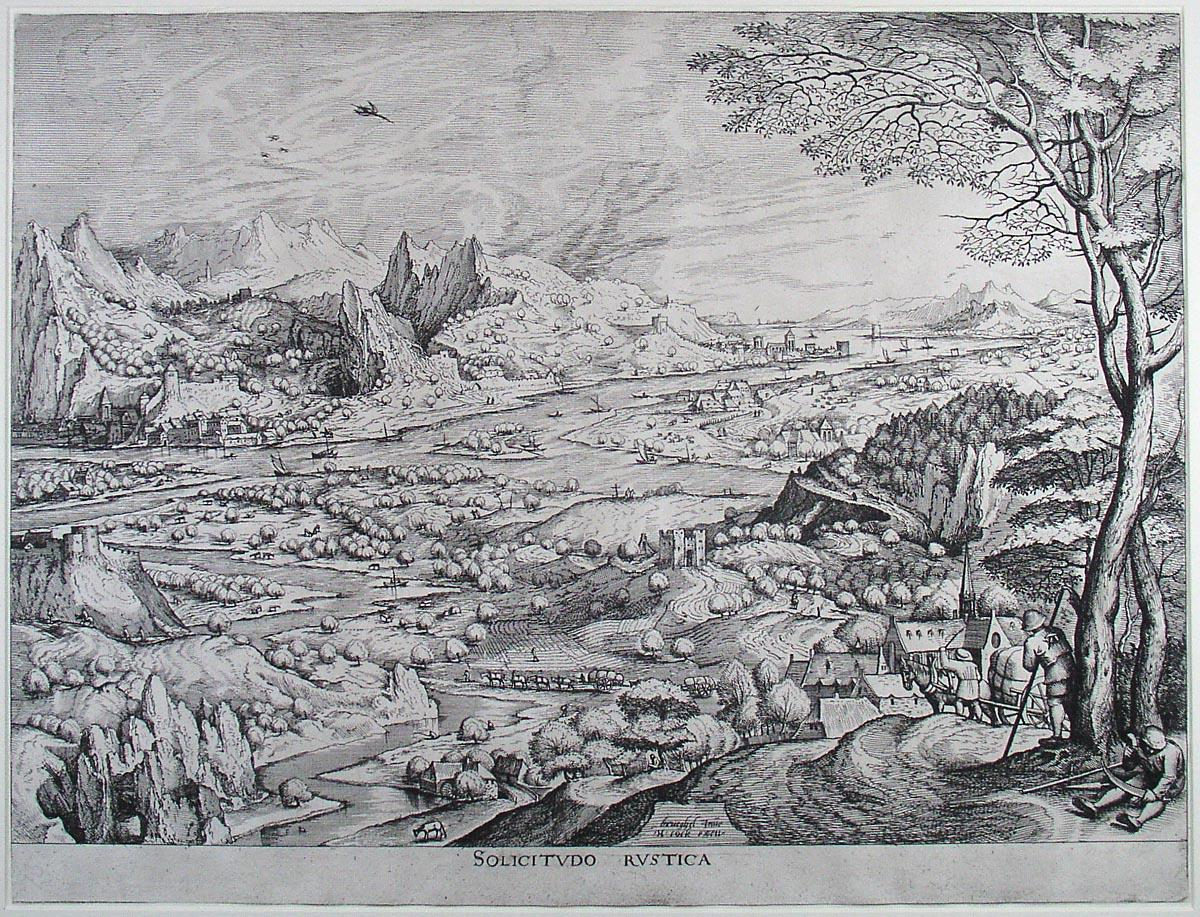How does the detailed landscape reflect the artistic priorities of the Renaissance period? The detailed landscape in this etching is a perfect reflection of the artistic priorities of the Renaissance period, which was characterized by a renewed interest in the natural world, humanism, and realistic representation. Artists of the Renaissance aimed to capture the world with an unprecedented level of detail and accuracy, emphasizing proportion, perspective, and the beauty of nature. This etching meticulously portrays the varied elements of the landscape, from the flowing river and lush trees to the distant, rugged mountains, showcasing the artist's dedication to naturalism. The inclusion of everyday life, such as the farmers working the fields, speaks to the period’s interest in the human experience and the integration of man with his environment. The use of perspective to create depth and the detailed rendering of both the landscape and architectural elements highlight the advancements in artistic techniques and the desire to depict the world as it truly appeared, making the natural world a subject of admiration and scholarly inquiry. If you could add a mythical creature to this landscape, what would it be and why? If I could add a mythical creature to this landscape, I would choose a majestic griffin. The griffin, with the body of a lion and the wings and head of an eagle, symbolizes courage, strength, and vigilance. Placing the griffin perched on a craggy outcrop of the mountains would add a mystical element to the scene, bridging the natural and fantastic realms. Its presence would suggest a guardian of the landscape, watching over the tranquil rural life below and warding off any threats from beyond the mountains. The griffin’s majestic and powerful form would complement the grandeur of the mountains and the serene beauty of the countryside, enhancing the narrative that this land is not only rich in natural beauty but also steeped in legend and magic. 